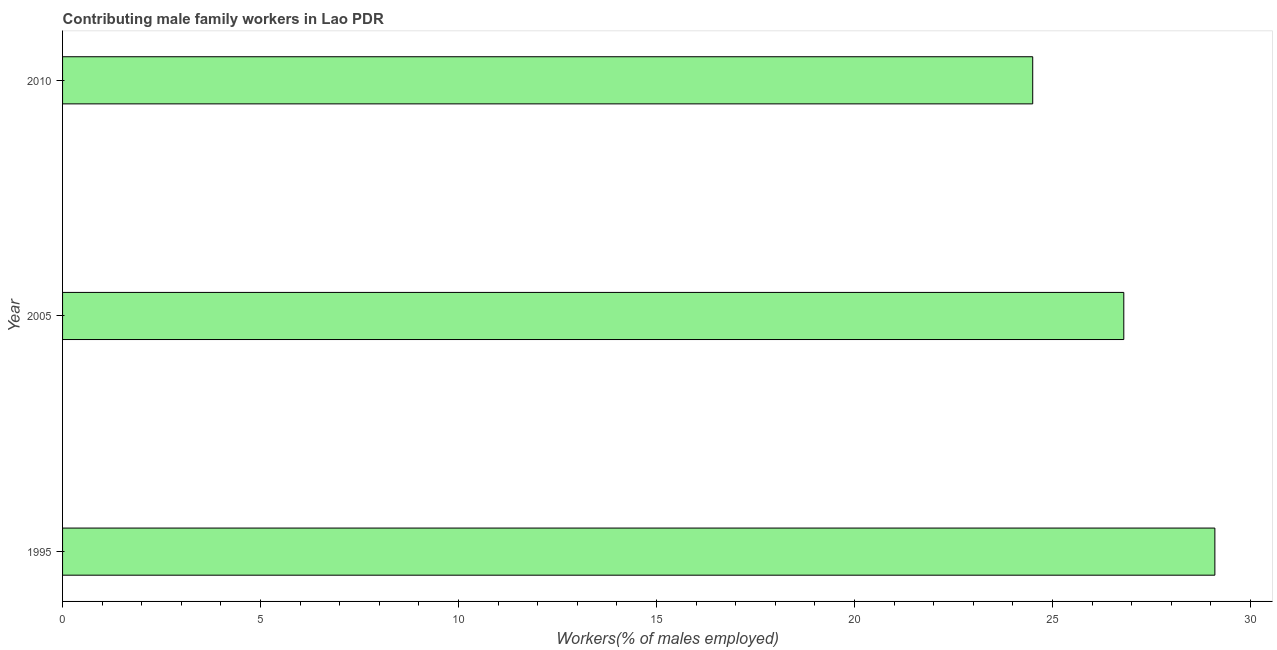What is the title of the graph?
Offer a very short reply. Contributing male family workers in Lao PDR. What is the label or title of the X-axis?
Offer a very short reply. Workers(% of males employed). What is the contributing male family workers in 1995?
Provide a succinct answer. 29.1. Across all years, what is the maximum contributing male family workers?
Provide a succinct answer. 29.1. What is the sum of the contributing male family workers?
Offer a very short reply. 80.4. What is the difference between the contributing male family workers in 2005 and 2010?
Your answer should be compact. 2.3. What is the average contributing male family workers per year?
Provide a succinct answer. 26.8. What is the median contributing male family workers?
Offer a terse response. 26.8. In how many years, is the contributing male family workers greater than 28 %?
Make the answer very short. 1. What is the ratio of the contributing male family workers in 2005 to that in 2010?
Give a very brief answer. 1.09. Is the contributing male family workers in 2005 less than that in 2010?
Provide a succinct answer. No. Is the difference between the contributing male family workers in 2005 and 2010 greater than the difference between any two years?
Your answer should be compact. No. What is the difference between the highest and the second highest contributing male family workers?
Make the answer very short. 2.3. Is the sum of the contributing male family workers in 2005 and 2010 greater than the maximum contributing male family workers across all years?
Offer a terse response. Yes. What is the difference between the highest and the lowest contributing male family workers?
Provide a succinct answer. 4.6. In how many years, is the contributing male family workers greater than the average contributing male family workers taken over all years?
Offer a terse response. 1. How many bars are there?
Give a very brief answer. 3. Are all the bars in the graph horizontal?
Your answer should be very brief. Yes. What is the Workers(% of males employed) in 1995?
Your response must be concise. 29.1. What is the Workers(% of males employed) of 2005?
Give a very brief answer. 26.8. What is the Workers(% of males employed) in 2010?
Make the answer very short. 24.5. What is the difference between the Workers(% of males employed) in 1995 and 2010?
Your response must be concise. 4.6. What is the ratio of the Workers(% of males employed) in 1995 to that in 2005?
Provide a short and direct response. 1.09. What is the ratio of the Workers(% of males employed) in 1995 to that in 2010?
Offer a very short reply. 1.19. What is the ratio of the Workers(% of males employed) in 2005 to that in 2010?
Provide a short and direct response. 1.09. 